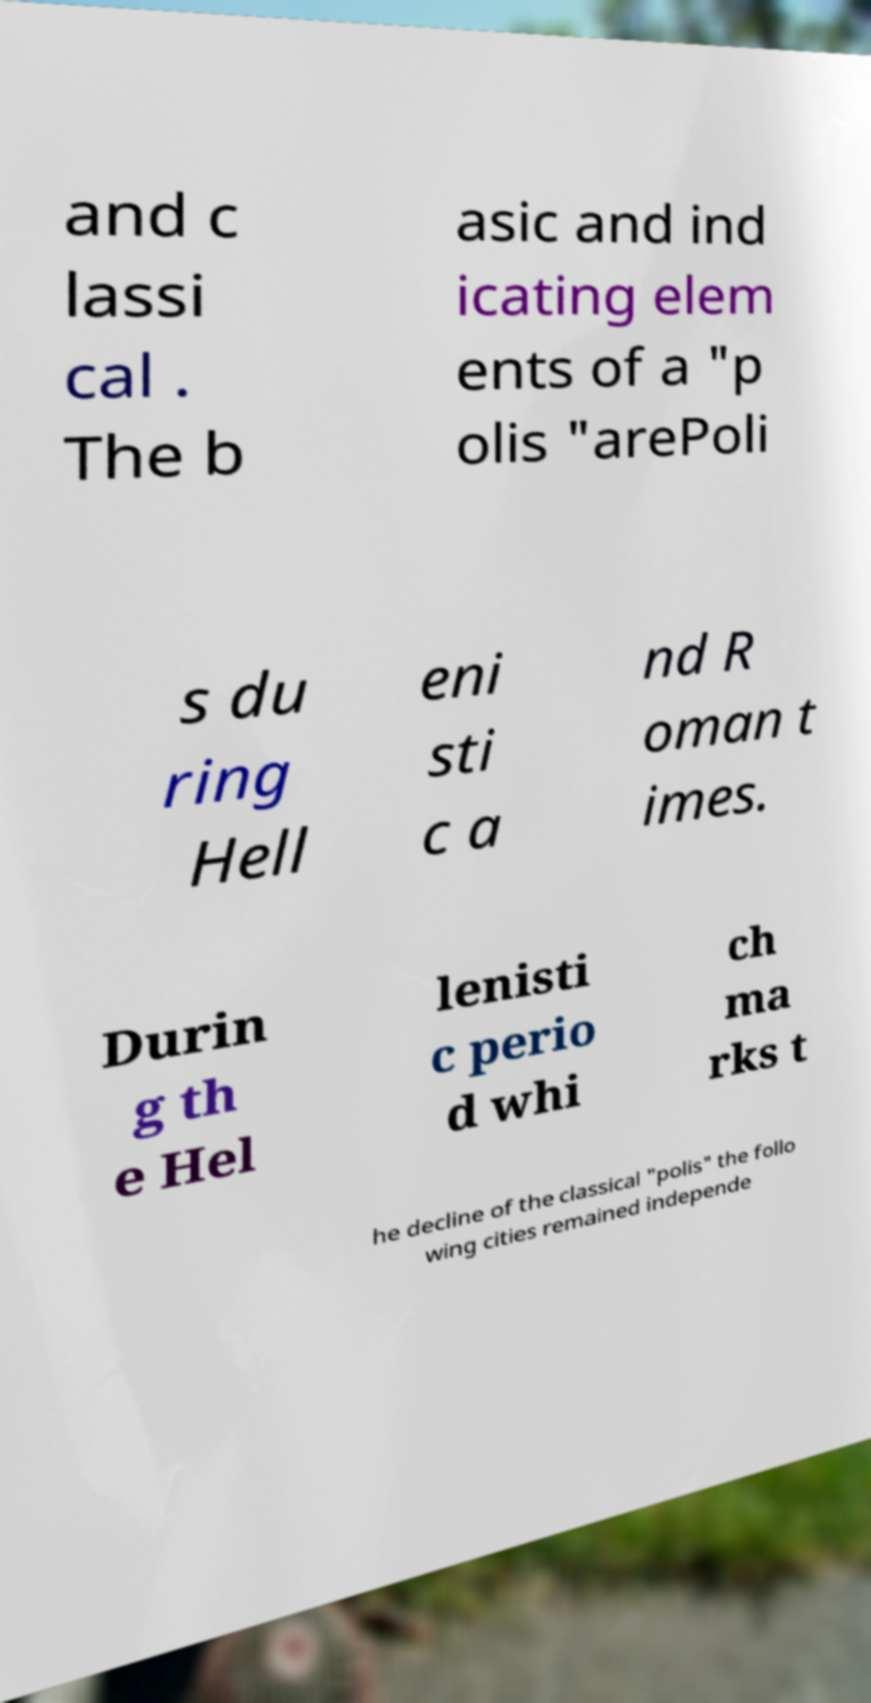What messages or text are displayed in this image? I need them in a readable, typed format. and c lassi cal . The b asic and ind icating elem ents of a "p olis "arePoli s du ring Hell eni sti c a nd R oman t imes. Durin g th e Hel lenisti c perio d whi ch ma rks t he decline of the classical "polis" the follo wing cities remained independe 